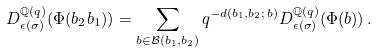<formula> <loc_0><loc_0><loc_500><loc_500>D ^ { \mathbb { Q } ( q ) } _ { \epsilon ( \sigma ) } ( \Phi ( b _ { 2 } b _ { 1 } ) ) = \sum _ { b \in \mathcal { B } ( b _ { 1 } , b _ { 2 } ) } q ^ { - d ( b _ { 1 } , b _ { 2 } ; \, b ) } D ^ { \mathbb { Q } ( q ) } _ { \epsilon ( \sigma ) } ( \Phi ( b ) ) \, .</formula> 